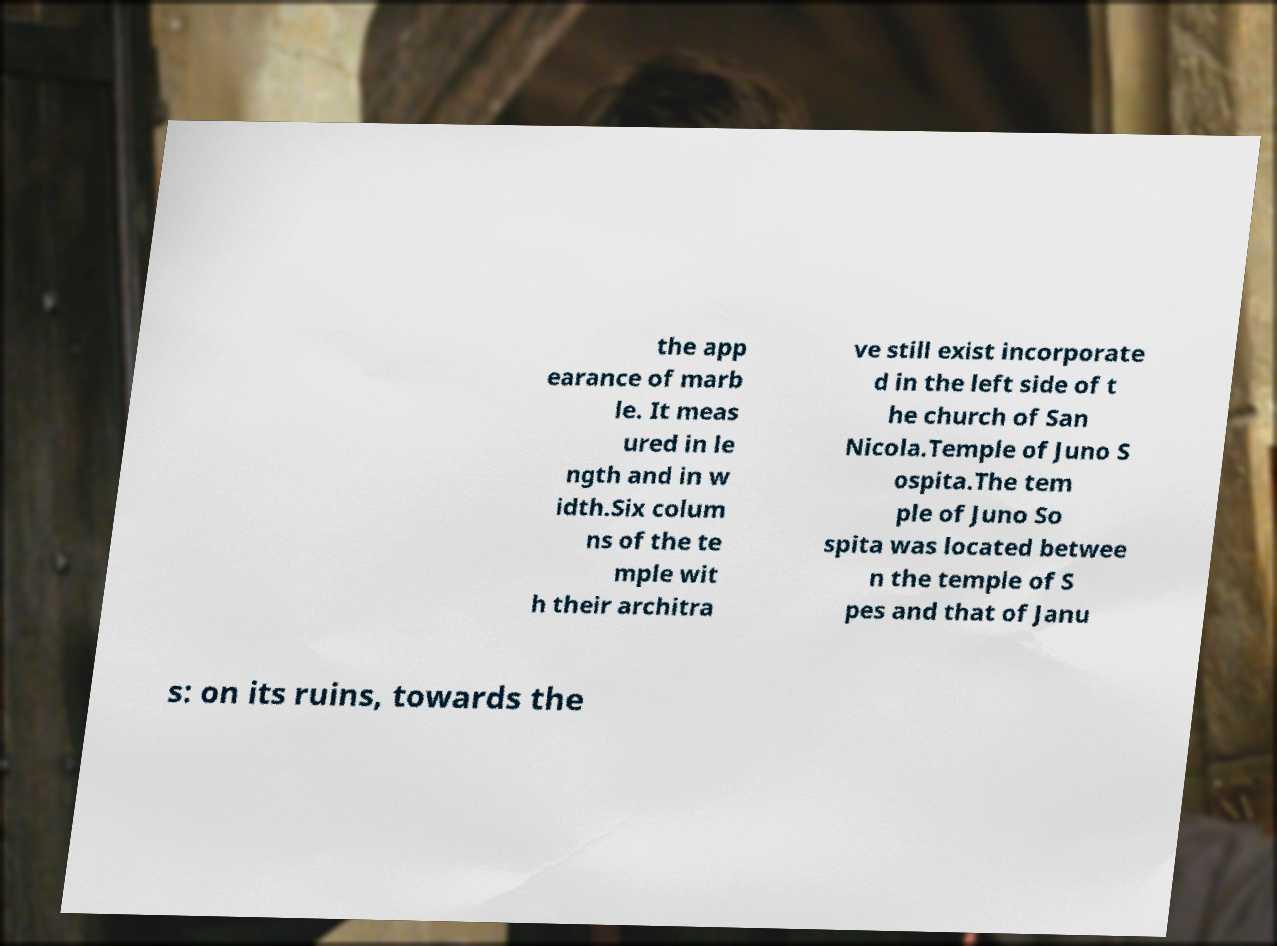What messages or text are displayed in this image? I need them in a readable, typed format. the app earance of marb le. It meas ured in le ngth and in w idth.Six colum ns of the te mple wit h their architra ve still exist incorporate d in the left side of t he church of San Nicola.Temple of Juno S ospita.The tem ple of Juno So spita was located betwee n the temple of S pes and that of Janu s: on its ruins, towards the 